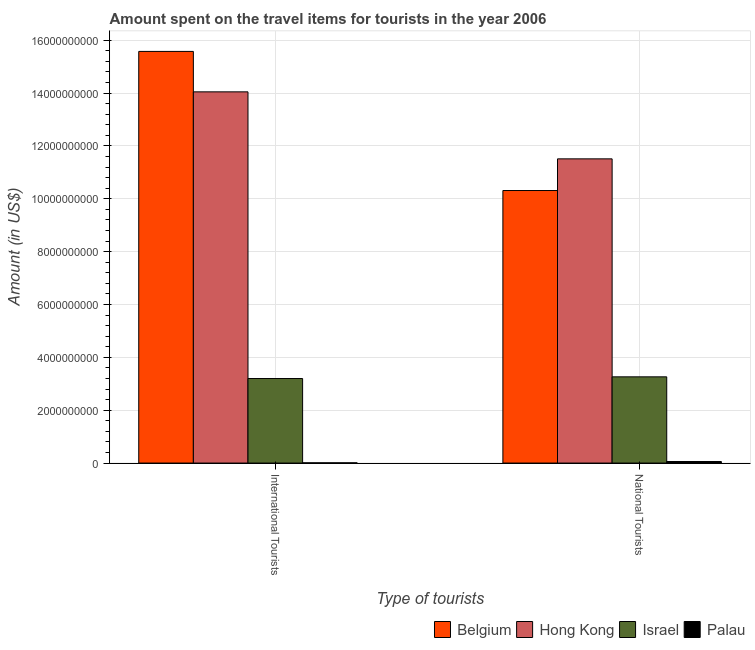How many different coloured bars are there?
Provide a short and direct response. 4. How many groups of bars are there?
Offer a terse response. 2. How many bars are there on the 1st tick from the left?
Your answer should be very brief. 4. How many bars are there on the 1st tick from the right?
Provide a short and direct response. 4. What is the label of the 2nd group of bars from the left?
Provide a succinct answer. National Tourists. What is the amount spent on travel items of international tourists in Hong Kong?
Offer a terse response. 1.40e+1. Across all countries, what is the maximum amount spent on travel items of national tourists?
Make the answer very short. 1.15e+1. Across all countries, what is the minimum amount spent on travel items of national tourists?
Your answer should be compact. 5.80e+07. In which country was the amount spent on travel items of national tourists maximum?
Your answer should be very brief. Hong Kong. In which country was the amount spent on travel items of international tourists minimum?
Your response must be concise. Palau. What is the total amount spent on travel items of national tourists in the graph?
Ensure brevity in your answer.  2.51e+1. What is the difference between the amount spent on travel items of international tourists in Hong Kong and that in Palau?
Your answer should be very brief. 1.40e+1. What is the difference between the amount spent on travel items of international tourists in Palau and the amount spent on travel items of national tourists in Hong Kong?
Give a very brief answer. -1.15e+1. What is the average amount spent on travel items of international tourists per country?
Offer a terse response. 8.21e+09. What is the difference between the amount spent on travel items of international tourists and amount spent on travel items of national tourists in Palau?
Offer a terse response. -4.99e+07. In how many countries, is the amount spent on travel items of international tourists greater than 12000000000 US$?
Your answer should be very brief. 2. What is the ratio of the amount spent on travel items of international tourists in Belgium to that in Hong Kong?
Your answer should be very brief. 1.11. What does the 1st bar from the left in International Tourists represents?
Provide a short and direct response. Belgium. What does the 1st bar from the right in International Tourists represents?
Your answer should be very brief. Palau. How many bars are there?
Your response must be concise. 8. What is the difference between two consecutive major ticks on the Y-axis?
Make the answer very short. 2.00e+09. Does the graph contain grids?
Keep it short and to the point. Yes. How are the legend labels stacked?
Your response must be concise. Horizontal. What is the title of the graph?
Make the answer very short. Amount spent on the travel items for tourists in the year 2006. Does "Dominican Republic" appear as one of the legend labels in the graph?
Offer a very short reply. No. What is the label or title of the X-axis?
Make the answer very short. Type of tourists. What is the label or title of the Y-axis?
Keep it short and to the point. Amount (in US$). What is the Amount (in US$) of Belgium in International Tourists?
Offer a terse response. 1.56e+1. What is the Amount (in US$) in Hong Kong in International Tourists?
Provide a succinct answer. 1.40e+1. What is the Amount (in US$) of Israel in International Tourists?
Your answer should be very brief. 3.20e+09. What is the Amount (in US$) of Palau in International Tourists?
Make the answer very short. 8.10e+06. What is the Amount (in US$) in Belgium in National Tourists?
Your answer should be compact. 1.03e+1. What is the Amount (in US$) of Hong Kong in National Tourists?
Ensure brevity in your answer.  1.15e+1. What is the Amount (in US$) in Israel in National Tourists?
Offer a very short reply. 3.26e+09. What is the Amount (in US$) in Palau in National Tourists?
Your response must be concise. 5.80e+07. Across all Type of tourists, what is the maximum Amount (in US$) in Belgium?
Ensure brevity in your answer.  1.56e+1. Across all Type of tourists, what is the maximum Amount (in US$) in Hong Kong?
Provide a succinct answer. 1.40e+1. Across all Type of tourists, what is the maximum Amount (in US$) of Israel?
Ensure brevity in your answer.  3.26e+09. Across all Type of tourists, what is the maximum Amount (in US$) of Palau?
Give a very brief answer. 5.80e+07. Across all Type of tourists, what is the minimum Amount (in US$) in Belgium?
Provide a short and direct response. 1.03e+1. Across all Type of tourists, what is the minimum Amount (in US$) of Hong Kong?
Offer a terse response. 1.15e+1. Across all Type of tourists, what is the minimum Amount (in US$) of Israel?
Provide a succinct answer. 3.20e+09. Across all Type of tourists, what is the minimum Amount (in US$) in Palau?
Make the answer very short. 8.10e+06. What is the total Amount (in US$) of Belgium in the graph?
Your answer should be very brief. 2.59e+1. What is the total Amount (in US$) in Hong Kong in the graph?
Provide a short and direct response. 2.56e+1. What is the total Amount (in US$) of Israel in the graph?
Keep it short and to the point. 6.46e+09. What is the total Amount (in US$) of Palau in the graph?
Give a very brief answer. 6.61e+07. What is the difference between the Amount (in US$) of Belgium in International Tourists and that in National Tourists?
Offer a terse response. 5.26e+09. What is the difference between the Amount (in US$) of Hong Kong in International Tourists and that in National Tourists?
Keep it short and to the point. 2.54e+09. What is the difference between the Amount (in US$) in Israel in International Tourists and that in National Tourists?
Make the answer very short. -6.40e+07. What is the difference between the Amount (in US$) in Palau in International Tourists and that in National Tourists?
Give a very brief answer. -4.99e+07. What is the difference between the Amount (in US$) of Belgium in International Tourists and the Amount (in US$) of Hong Kong in National Tourists?
Make the answer very short. 4.06e+09. What is the difference between the Amount (in US$) in Belgium in International Tourists and the Amount (in US$) in Israel in National Tourists?
Keep it short and to the point. 1.23e+1. What is the difference between the Amount (in US$) in Belgium in International Tourists and the Amount (in US$) in Palau in National Tourists?
Provide a succinct answer. 1.55e+1. What is the difference between the Amount (in US$) in Hong Kong in International Tourists and the Amount (in US$) in Israel in National Tourists?
Offer a very short reply. 1.08e+1. What is the difference between the Amount (in US$) in Hong Kong in International Tourists and the Amount (in US$) in Palau in National Tourists?
Your response must be concise. 1.40e+1. What is the difference between the Amount (in US$) of Israel in International Tourists and the Amount (in US$) of Palau in National Tourists?
Provide a short and direct response. 3.14e+09. What is the average Amount (in US$) in Belgium per Type of tourists?
Keep it short and to the point. 1.29e+1. What is the average Amount (in US$) in Hong Kong per Type of tourists?
Your response must be concise. 1.28e+1. What is the average Amount (in US$) in Israel per Type of tourists?
Offer a very short reply. 3.23e+09. What is the average Amount (in US$) in Palau per Type of tourists?
Ensure brevity in your answer.  3.30e+07. What is the difference between the Amount (in US$) in Belgium and Amount (in US$) in Hong Kong in International Tourists?
Provide a succinct answer. 1.53e+09. What is the difference between the Amount (in US$) of Belgium and Amount (in US$) of Israel in International Tourists?
Your answer should be compact. 1.24e+1. What is the difference between the Amount (in US$) of Belgium and Amount (in US$) of Palau in International Tourists?
Provide a short and direct response. 1.56e+1. What is the difference between the Amount (in US$) in Hong Kong and Amount (in US$) in Israel in International Tourists?
Provide a short and direct response. 1.08e+1. What is the difference between the Amount (in US$) of Hong Kong and Amount (in US$) of Palau in International Tourists?
Give a very brief answer. 1.40e+1. What is the difference between the Amount (in US$) of Israel and Amount (in US$) of Palau in International Tourists?
Keep it short and to the point. 3.19e+09. What is the difference between the Amount (in US$) of Belgium and Amount (in US$) of Hong Kong in National Tourists?
Ensure brevity in your answer.  -1.20e+09. What is the difference between the Amount (in US$) in Belgium and Amount (in US$) in Israel in National Tourists?
Provide a succinct answer. 7.05e+09. What is the difference between the Amount (in US$) of Belgium and Amount (in US$) of Palau in National Tourists?
Your answer should be very brief. 1.03e+1. What is the difference between the Amount (in US$) of Hong Kong and Amount (in US$) of Israel in National Tourists?
Provide a succinct answer. 8.25e+09. What is the difference between the Amount (in US$) in Hong Kong and Amount (in US$) in Palau in National Tourists?
Provide a short and direct response. 1.15e+1. What is the difference between the Amount (in US$) in Israel and Amount (in US$) in Palau in National Tourists?
Your answer should be very brief. 3.20e+09. What is the ratio of the Amount (in US$) in Belgium in International Tourists to that in National Tourists?
Ensure brevity in your answer.  1.51. What is the ratio of the Amount (in US$) of Hong Kong in International Tourists to that in National Tourists?
Make the answer very short. 1.22. What is the ratio of the Amount (in US$) of Israel in International Tourists to that in National Tourists?
Provide a succinct answer. 0.98. What is the ratio of the Amount (in US$) of Palau in International Tourists to that in National Tourists?
Give a very brief answer. 0.14. What is the difference between the highest and the second highest Amount (in US$) in Belgium?
Your answer should be compact. 5.26e+09. What is the difference between the highest and the second highest Amount (in US$) of Hong Kong?
Make the answer very short. 2.54e+09. What is the difference between the highest and the second highest Amount (in US$) of Israel?
Give a very brief answer. 6.40e+07. What is the difference between the highest and the second highest Amount (in US$) of Palau?
Offer a very short reply. 4.99e+07. What is the difference between the highest and the lowest Amount (in US$) in Belgium?
Make the answer very short. 5.26e+09. What is the difference between the highest and the lowest Amount (in US$) in Hong Kong?
Keep it short and to the point. 2.54e+09. What is the difference between the highest and the lowest Amount (in US$) in Israel?
Make the answer very short. 6.40e+07. What is the difference between the highest and the lowest Amount (in US$) in Palau?
Keep it short and to the point. 4.99e+07. 